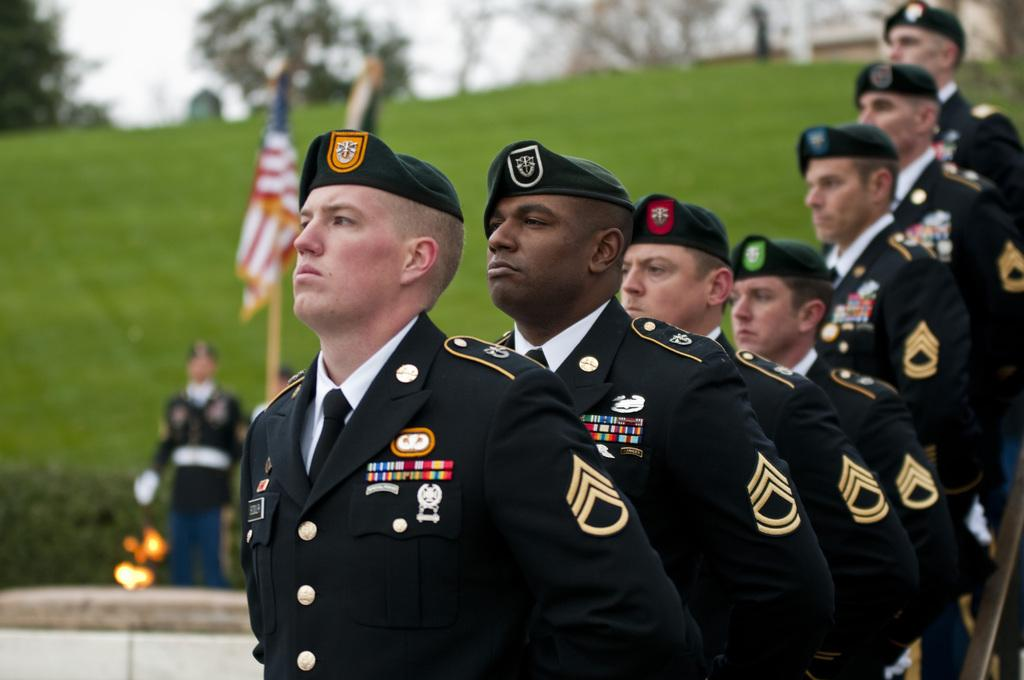What is the main subject of the image? The main subject of the image is a group of men. What are the men doing in the image? The men are standing in the image. What are the men wearing in the image? The men are wearing black color uniforms and caps in the image. What can be seen in the background of the image? In the background of the image, there is a flag, grass, trees, and the sky. What type of plant is the men shaking in the image? There is no plant present in the image, nor are the men shaking anything. 